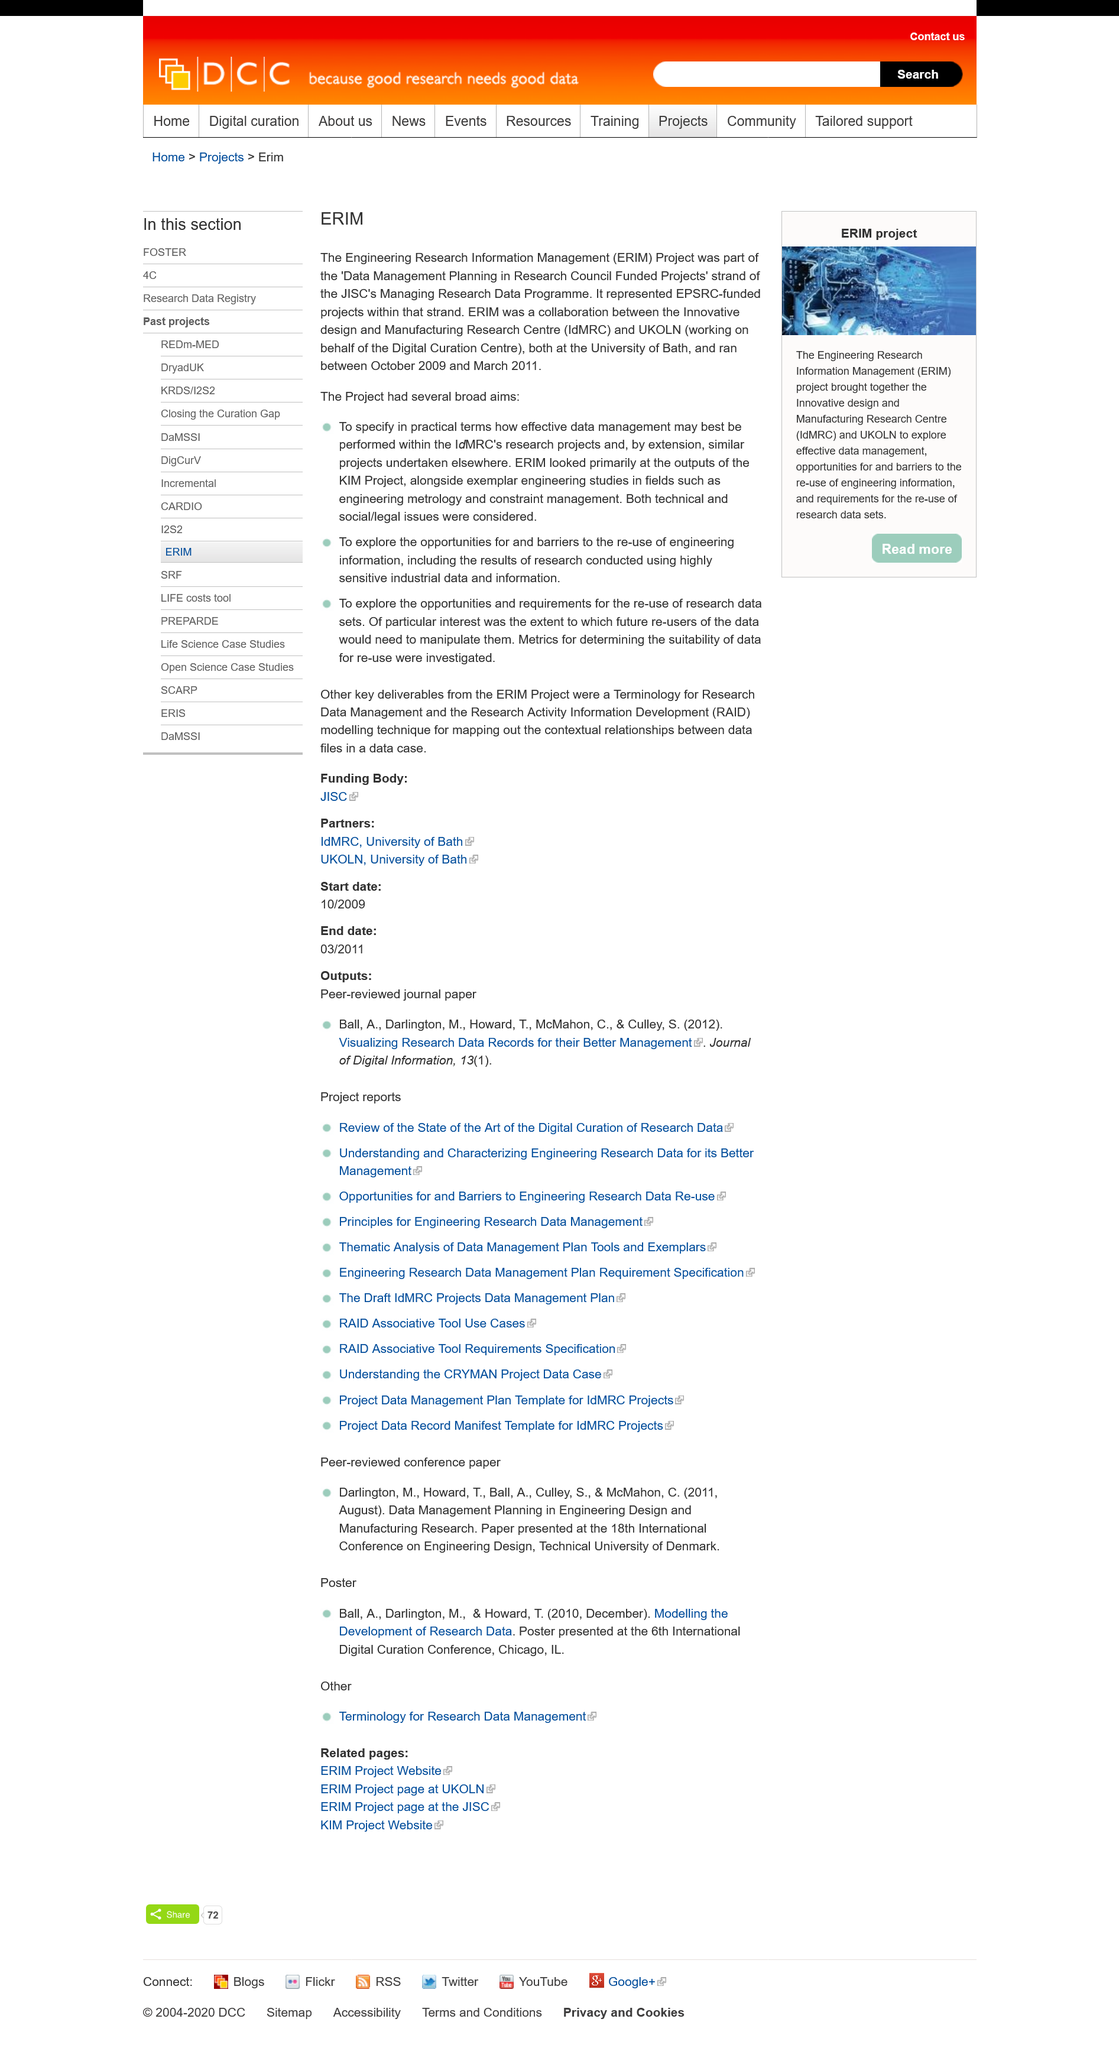Give some essential details in this illustration. The European Research Institute on Micro- and Nanotechnology (ERIM) was a collaboration between the Innovative Design and Manufacturing Research Centre (IdMCR) and UKOLN, which were two organizations that worked together to conduct research and development in the field of micro- and nanotechnology. The IdMCR and UKOLN are located at the University of Bath. The acronym ERIM stands for the Engineering Research Information Management program, which is dedicated to advancing the field of engineering through the use of cutting-edge research and management techniques. 